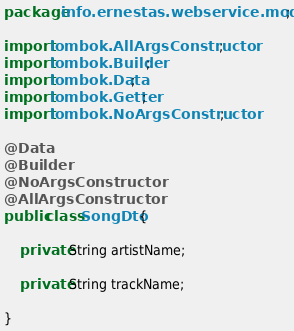<code> <loc_0><loc_0><loc_500><loc_500><_Java_>package info.ernestas.webservice.model.dto;

import lombok.AllArgsConstructor;
import lombok.Builder;
import lombok.Data;
import lombok.Getter;
import lombok.NoArgsConstructor;

@Data
@Builder
@NoArgsConstructor
@AllArgsConstructor
public class SongDto {

    private String artistName;

    private String trackName;

}
</code> 